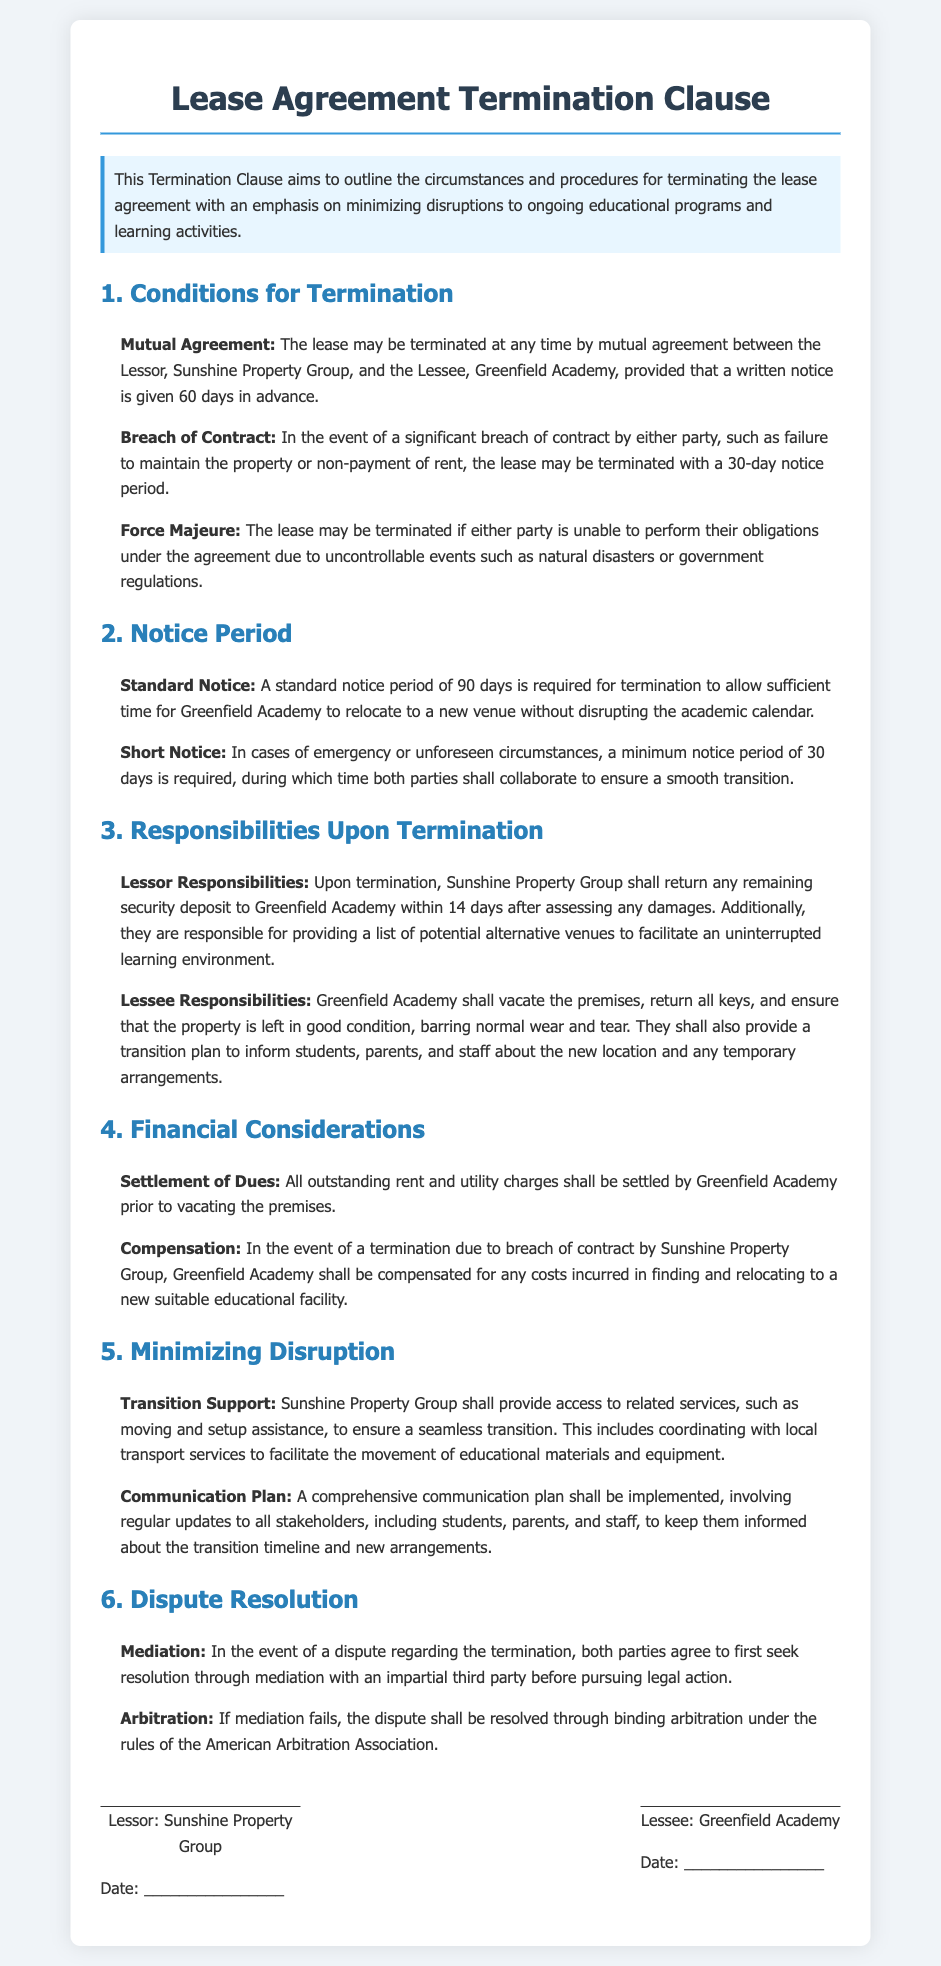What is the notice period for standard termination? The document specifies a standard notice period of 90 days for termination, allowing sufficient time for relocation.
Answer: 90 days What could lead to termination due to breach of contract? A significant breach of contract by either party, such as failure to maintain the property or non-payment of rent, could lead to this termination.
Answer: Significant breach of contract What is the maximum notice period for short notice termination? The document states that a minimum notice period of 30 days is required in cases of emergency or unforeseen circumstances.
Answer: 30 days Who is responsible for providing a list of alternative venues? Sunshine Property Group is responsible for providing a list of potential alternative venues to facilitate an uninterrupted learning environment upon termination.
Answer: Sunshine Property Group What kind of support will Sunshine Property Group provide upon termination? Sunshine Property Group shall provide access to related services, such as moving and setup assistance, to ensure a seamless transition.
Answer: Moving and setup assistance What must Greenfield Academy do before vacating the premises? Greenfield Academy must settle all outstanding rent and utility charges prior to vacating the premises.
Answer: Settle all outstanding charges How will disputes regarding termination be initially resolved? Both parties agree to first seek resolution through mediation with an impartial third party before pursuing legal action.
Answer: Mediation What is required for a lease termination by mutual agreement? A written notice is required to be given 60 days in advance for a termination by mutual agreement.
Answer: 60 days written notice 